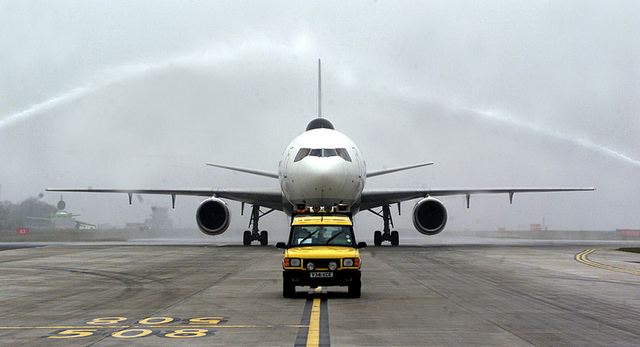Identify the text displayed in this image. 508 508 